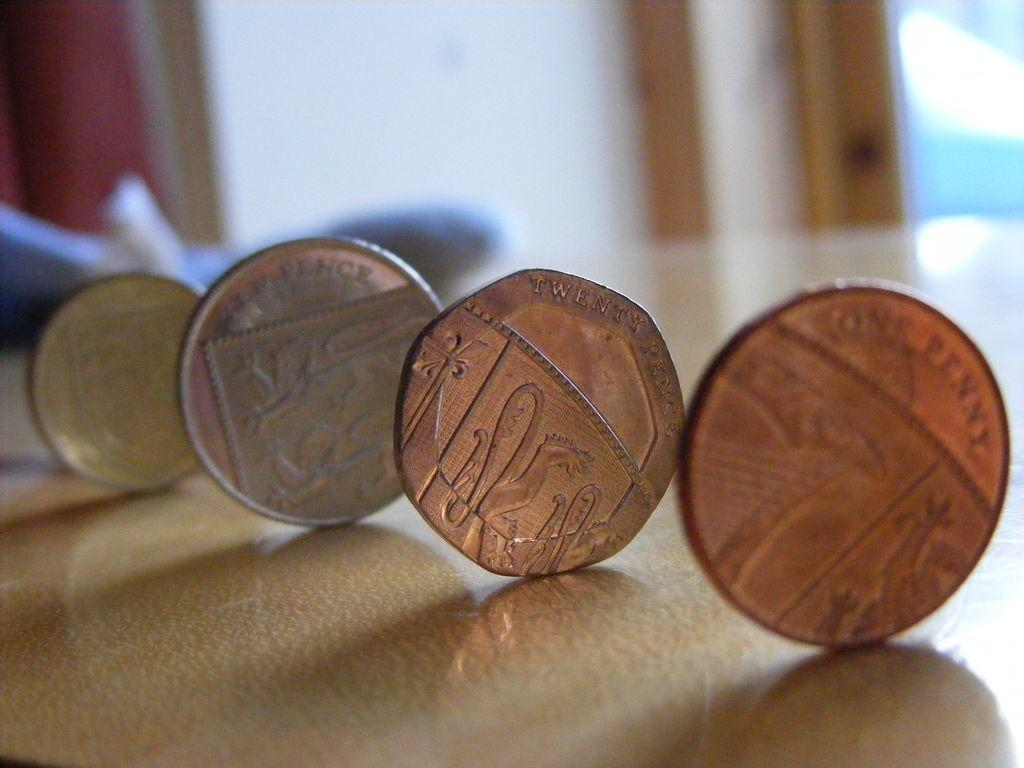<image>
Render a clear and concise summary of the photo. four coins on a table standing up on their sides, one reading 'one penny' 